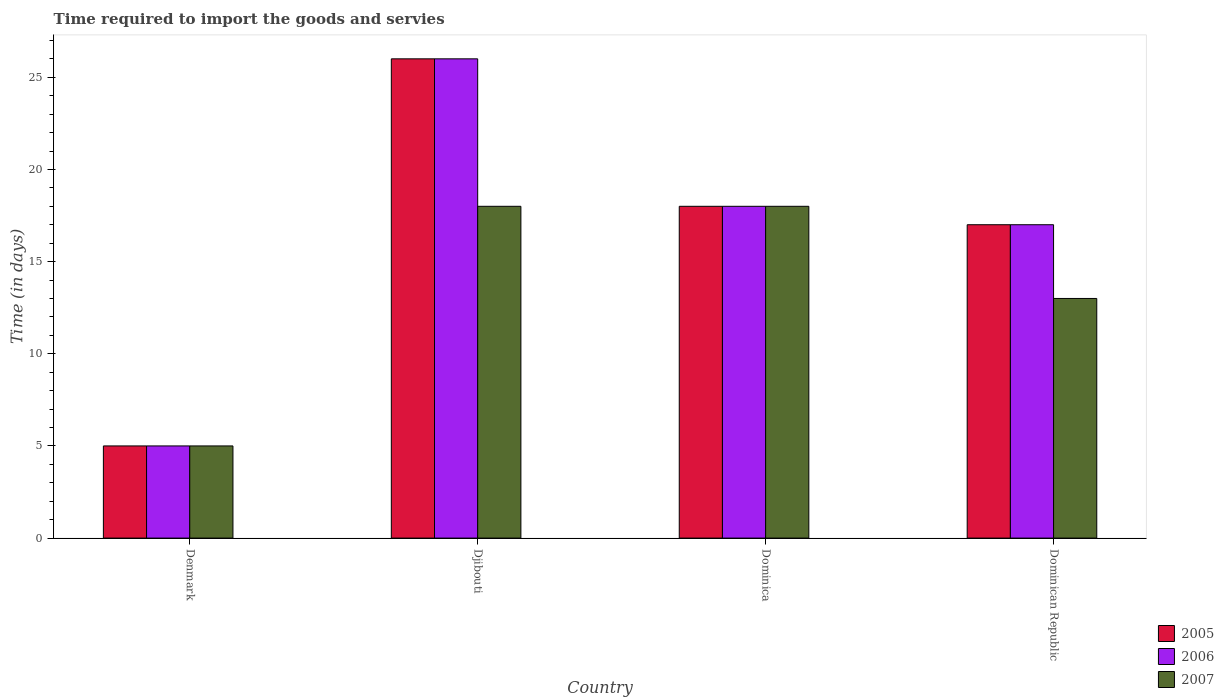How many different coloured bars are there?
Offer a terse response. 3. What is the label of the 4th group of bars from the left?
Give a very brief answer. Dominican Republic. In how many cases, is the number of bars for a given country not equal to the number of legend labels?
Provide a short and direct response. 0. What is the number of days required to import the goods and services in 2007 in Denmark?
Give a very brief answer. 5. In which country was the number of days required to import the goods and services in 2007 maximum?
Your answer should be compact. Djibouti. In which country was the number of days required to import the goods and services in 2007 minimum?
Offer a terse response. Denmark. What is the total number of days required to import the goods and services in 2007 in the graph?
Give a very brief answer. 54. What is the difference between the number of days required to import the goods and services in 2006 in Dominican Republic and the number of days required to import the goods and services in 2005 in Denmark?
Your answer should be compact. 12. In how many countries, is the number of days required to import the goods and services in 2006 greater than 21 days?
Your answer should be compact. 1. What is the ratio of the number of days required to import the goods and services in 2006 in Djibouti to that in Dominican Republic?
Offer a very short reply. 1.53. Is the number of days required to import the goods and services in 2006 in Djibouti less than that in Dominica?
Ensure brevity in your answer.  No. Is the difference between the number of days required to import the goods and services in 2005 in Denmark and Dominican Republic greater than the difference between the number of days required to import the goods and services in 2007 in Denmark and Dominican Republic?
Offer a very short reply. No. Is the sum of the number of days required to import the goods and services in 2007 in Denmark and Dominican Republic greater than the maximum number of days required to import the goods and services in 2006 across all countries?
Give a very brief answer. No. How many bars are there?
Give a very brief answer. 12. Are all the bars in the graph horizontal?
Keep it short and to the point. No. How many countries are there in the graph?
Make the answer very short. 4. Are the values on the major ticks of Y-axis written in scientific E-notation?
Keep it short and to the point. No. Does the graph contain any zero values?
Provide a succinct answer. No. How many legend labels are there?
Your answer should be very brief. 3. How are the legend labels stacked?
Offer a terse response. Vertical. What is the title of the graph?
Offer a very short reply. Time required to import the goods and servies. Does "1998" appear as one of the legend labels in the graph?
Keep it short and to the point. No. What is the label or title of the X-axis?
Ensure brevity in your answer.  Country. What is the label or title of the Y-axis?
Ensure brevity in your answer.  Time (in days). What is the Time (in days) in 2005 in Denmark?
Offer a very short reply. 5. What is the Time (in days) in 2006 in Denmark?
Offer a very short reply. 5. What is the Time (in days) of 2005 in Dominican Republic?
Ensure brevity in your answer.  17. What is the Time (in days) of 2007 in Dominican Republic?
Your answer should be very brief. 13. What is the total Time (in days) in 2006 in the graph?
Your answer should be very brief. 66. What is the total Time (in days) of 2007 in the graph?
Your response must be concise. 54. What is the difference between the Time (in days) of 2006 in Denmark and that in Djibouti?
Provide a succinct answer. -21. What is the difference between the Time (in days) in 2007 in Denmark and that in Djibouti?
Provide a succinct answer. -13. What is the difference between the Time (in days) in 2006 in Denmark and that in Dominica?
Keep it short and to the point. -13. What is the difference between the Time (in days) of 2007 in Denmark and that in Dominica?
Provide a short and direct response. -13. What is the difference between the Time (in days) in 2006 in Denmark and that in Dominican Republic?
Give a very brief answer. -12. What is the difference between the Time (in days) in 2005 in Djibouti and that in Dominica?
Make the answer very short. 8. What is the difference between the Time (in days) in 2006 in Djibouti and that in Dominica?
Offer a very short reply. 8. What is the difference between the Time (in days) of 2006 in Djibouti and that in Dominican Republic?
Your answer should be compact. 9. What is the difference between the Time (in days) in 2005 in Dominica and that in Dominican Republic?
Make the answer very short. 1. What is the difference between the Time (in days) of 2006 in Dominica and that in Dominican Republic?
Provide a short and direct response. 1. What is the difference between the Time (in days) in 2005 in Denmark and the Time (in days) in 2006 in Djibouti?
Offer a very short reply. -21. What is the difference between the Time (in days) of 2005 in Denmark and the Time (in days) of 2007 in Djibouti?
Provide a succinct answer. -13. What is the difference between the Time (in days) in 2005 in Denmark and the Time (in days) in 2007 in Dominica?
Your answer should be very brief. -13. What is the difference between the Time (in days) of 2005 in Denmark and the Time (in days) of 2006 in Dominican Republic?
Offer a terse response. -12. What is the difference between the Time (in days) of 2005 in Denmark and the Time (in days) of 2007 in Dominican Republic?
Offer a very short reply. -8. What is the difference between the Time (in days) of 2006 in Denmark and the Time (in days) of 2007 in Dominican Republic?
Offer a terse response. -8. What is the difference between the Time (in days) in 2005 in Djibouti and the Time (in days) in 2006 in Dominican Republic?
Offer a very short reply. 9. What is the difference between the Time (in days) in 2005 in Djibouti and the Time (in days) in 2007 in Dominican Republic?
Offer a terse response. 13. What is the difference between the Time (in days) of 2005 in Dominica and the Time (in days) of 2006 in Dominican Republic?
Your response must be concise. 1. What is the difference between the Time (in days) in 2005 in Dominica and the Time (in days) in 2007 in Dominican Republic?
Ensure brevity in your answer.  5. What is the difference between the Time (in days) in 2006 in Dominica and the Time (in days) in 2007 in Dominican Republic?
Your answer should be compact. 5. What is the average Time (in days) in 2005 per country?
Give a very brief answer. 16.5. What is the average Time (in days) of 2006 per country?
Offer a terse response. 16.5. What is the average Time (in days) in 2007 per country?
Your response must be concise. 13.5. What is the difference between the Time (in days) in 2005 and Time (in days) in 2006 in Denmark?
Offer a very short reply. 0. What is the difference between the Time (in days) in 2005 and Time (in days) in 2006 in Djibouti?
Offer a very short reply. 0. What is the difference between the Time (in days) in 2005 and Time (in days) in 2007 in Dominica?
Your answer should be very brief. 0. What is the ratio of the Time (in days) of 2005 in Denmark to that in Djibouti?
Offer a very short reply. 0.19. What is the ratio of the Time (in days) of 2006 in Denmark to that in Djibouti?
Your answer should be compact. 0.19. What is the ratio of the Time (in days) of 2007 in Denmark to that in Djibouti?
Offer a terse response. 0.28. What is the ratio of the Time (in days) of 2005 in Denmark to that in Dominica?
Your answer should be very brief. 0.28. What is the ratio of the Time (in days) in 2006 in Denmark to that in Dominica?
Provide a short and direct response. 0.28. What is the ratio of the Time (in days) of 2007 in Denmark to that in Dominica?
Provide a succinct answer. 0.28. What is the ratio of the Time (in days) of 2005 in Denmark to that in Dominican Republic?
Keep it short and to the point. 0.29. What is the ratio of the Time (in days) in 2006 in Denmark to that in Dominican Republic?
Ensure brevity in your answer.  0.29. What is the ratio of the Time (in days) in 2007 in Denmark to that in Dominican Republic?
Your answer should be compact. 0.38. What is the ratio of the Time (in days) of 2005 in Djibouti to that in Dominica?
Ensure brevity in your answer.  1.44. What is the ratio of the Time (in days) in 2006 in Djibouti to that in Dominica?
Offer a very short reply. 1.44. What is the ratio of the Time (in days) of 2007 in Djibouti to that in Dominica?
Keep it short and to the point. 1. What is the ratio of the Time (in days) in 2005 in Djibouti to that in Dominican Republic?
Your response must be concise. 1.53. What is the ratio of the Time (in days) of 2006 in Djibouti to that in Dominican Republic?
Provide a succinct answer. 1.53. What is the ratio of the Time (in days) in 2007 in Djibouti to that in Dominican Republic?
Provide a succinct answer. 1.38. What is the ratio of the Time (in days) in 2005 in Dominica to that in Dominican Republic?
Make the answer very short. 1.06. What is the ratio of the Time (in days) of 2006 in Dominica to that in Dominican Republic?
Offer a very short reply. 1.06. What is the ratio of the Time (in days) of 2007 in Dominica to that in Dominican Republic?
Give a very brief answer. 1.38. What is the difference between the highest and the lowest Time (in days) of 2005?
Your answer should be very brief. 21. What is the difference between the highest and the lowest Time (in days) in 2006?
Provide a succinct answer. 21. 